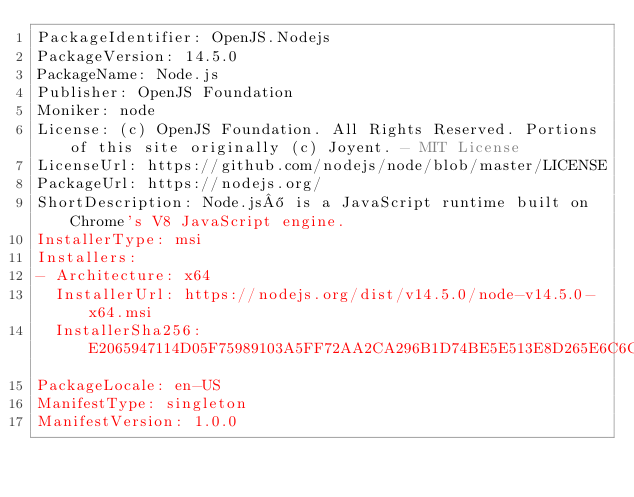<code> <loc_0><loc_0><loc_500><loc_500><_YAML_>PackageIdentifier: OpenJS.Nodejs
PackageVersion: 14.5.0
PackageName: Node.js
Publisher: OpenJS Foundation
Moniker: node
License: (c) OpenJS Foundation. All Rights Reserved. Portions of this site originally (c) Joyent. - MIT License
LicenseUrl: https://github.com/nodejs/node/blob/master/LICENSE
PackageUrl: https://nodejs.org/
ShortDescription: Node.js® is a JavaScript runtime built on Chrome's V8 JavaScript engine.
InstallerType: msi
Installers:
- Architecture: x64
  InstallerUrl: https://nodejs.org/dist/v14.5.0/node-v14.5.0-x64.msi
  InstallerSha256: E2065947114D05F75989103A5FF72AA2CA296B1D74BE5E513E8D265E6C6CB3C2
PackageLocale: en-US
ManifestType: singleton
ManifestVersion: 1.0.0
</code> 